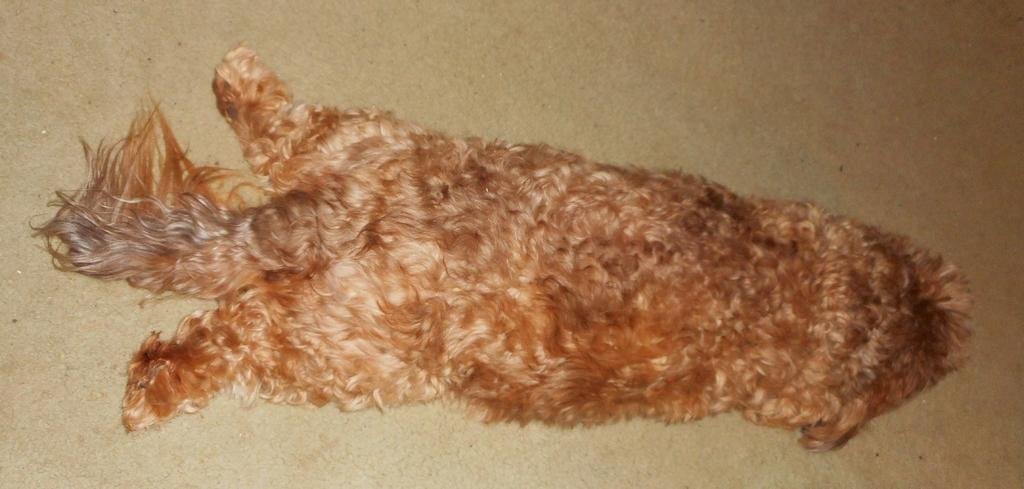What type of animal is present in the image? There is a dog in the image. Where is the dog located in the image? The dog is on the floor. What type of apparel is the dog wearing in the image? There is no apparel visible on the dog in the image. 